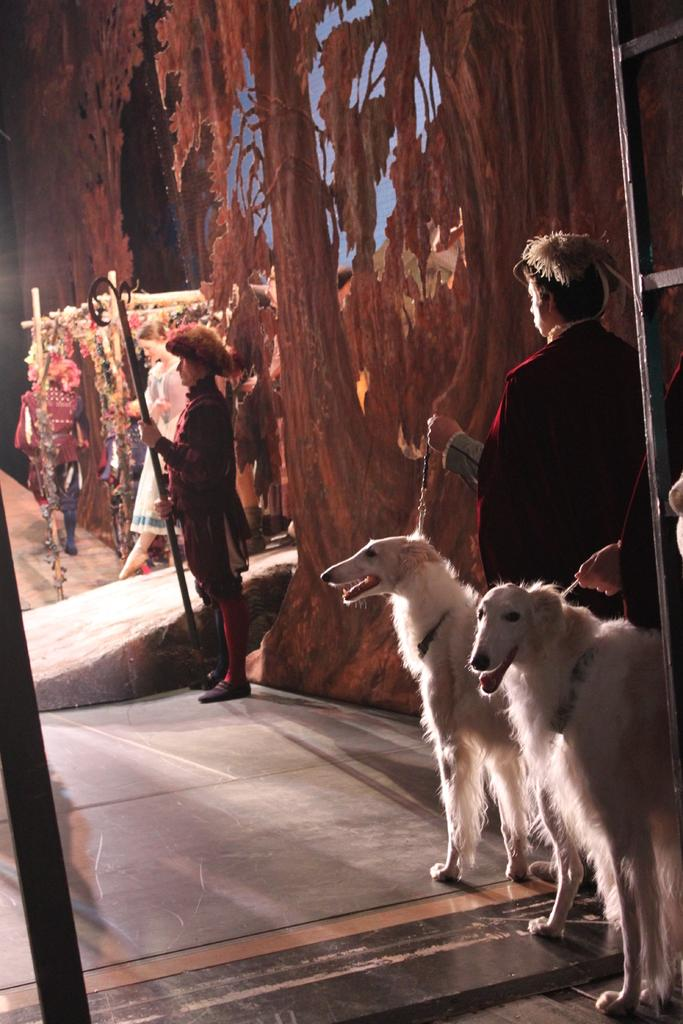What is the man in the image holding? The man is holding two dogs in the image. Can you describe the other person in the image? There is another man standing in the image. What type of cap is the plant wearing in the image? There is no plant or cap present in the image. 